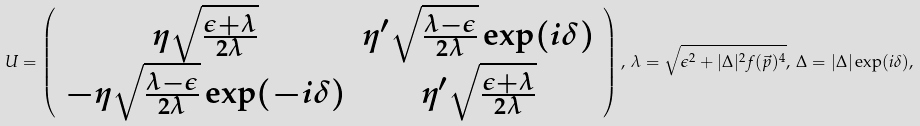<formula> <loc_0><loc_0><loc_500><loc_500>U = \left ( \begin{array} { c c } \eta \sqrt { \frac { \epsilon + \lambda } { 2 \lambda } } & \eta ^ { \prime } \sqrt { \frac { \lambda - \epsilon } { 2 \lambda } } \exp ( i \delta ) \\ - \eta \sqrt { \frac { \lambda - \epsilon } { 2 \lambda } } \exp ( - i \delta ) & \eta ^ { \prime } \sqrt { \frac { \epsilon + \lambda } { 2 \lambda } } \\ \end{array} \right ) , \, \lambda = \sqrt { \epsilon ^ { 2 } + | \Delta | ^ { 2 } f ( \vec { p } ) ^ { 4 } } , \, \Delta = | \Delta | \exp ( i \delta ) ,</formula> 